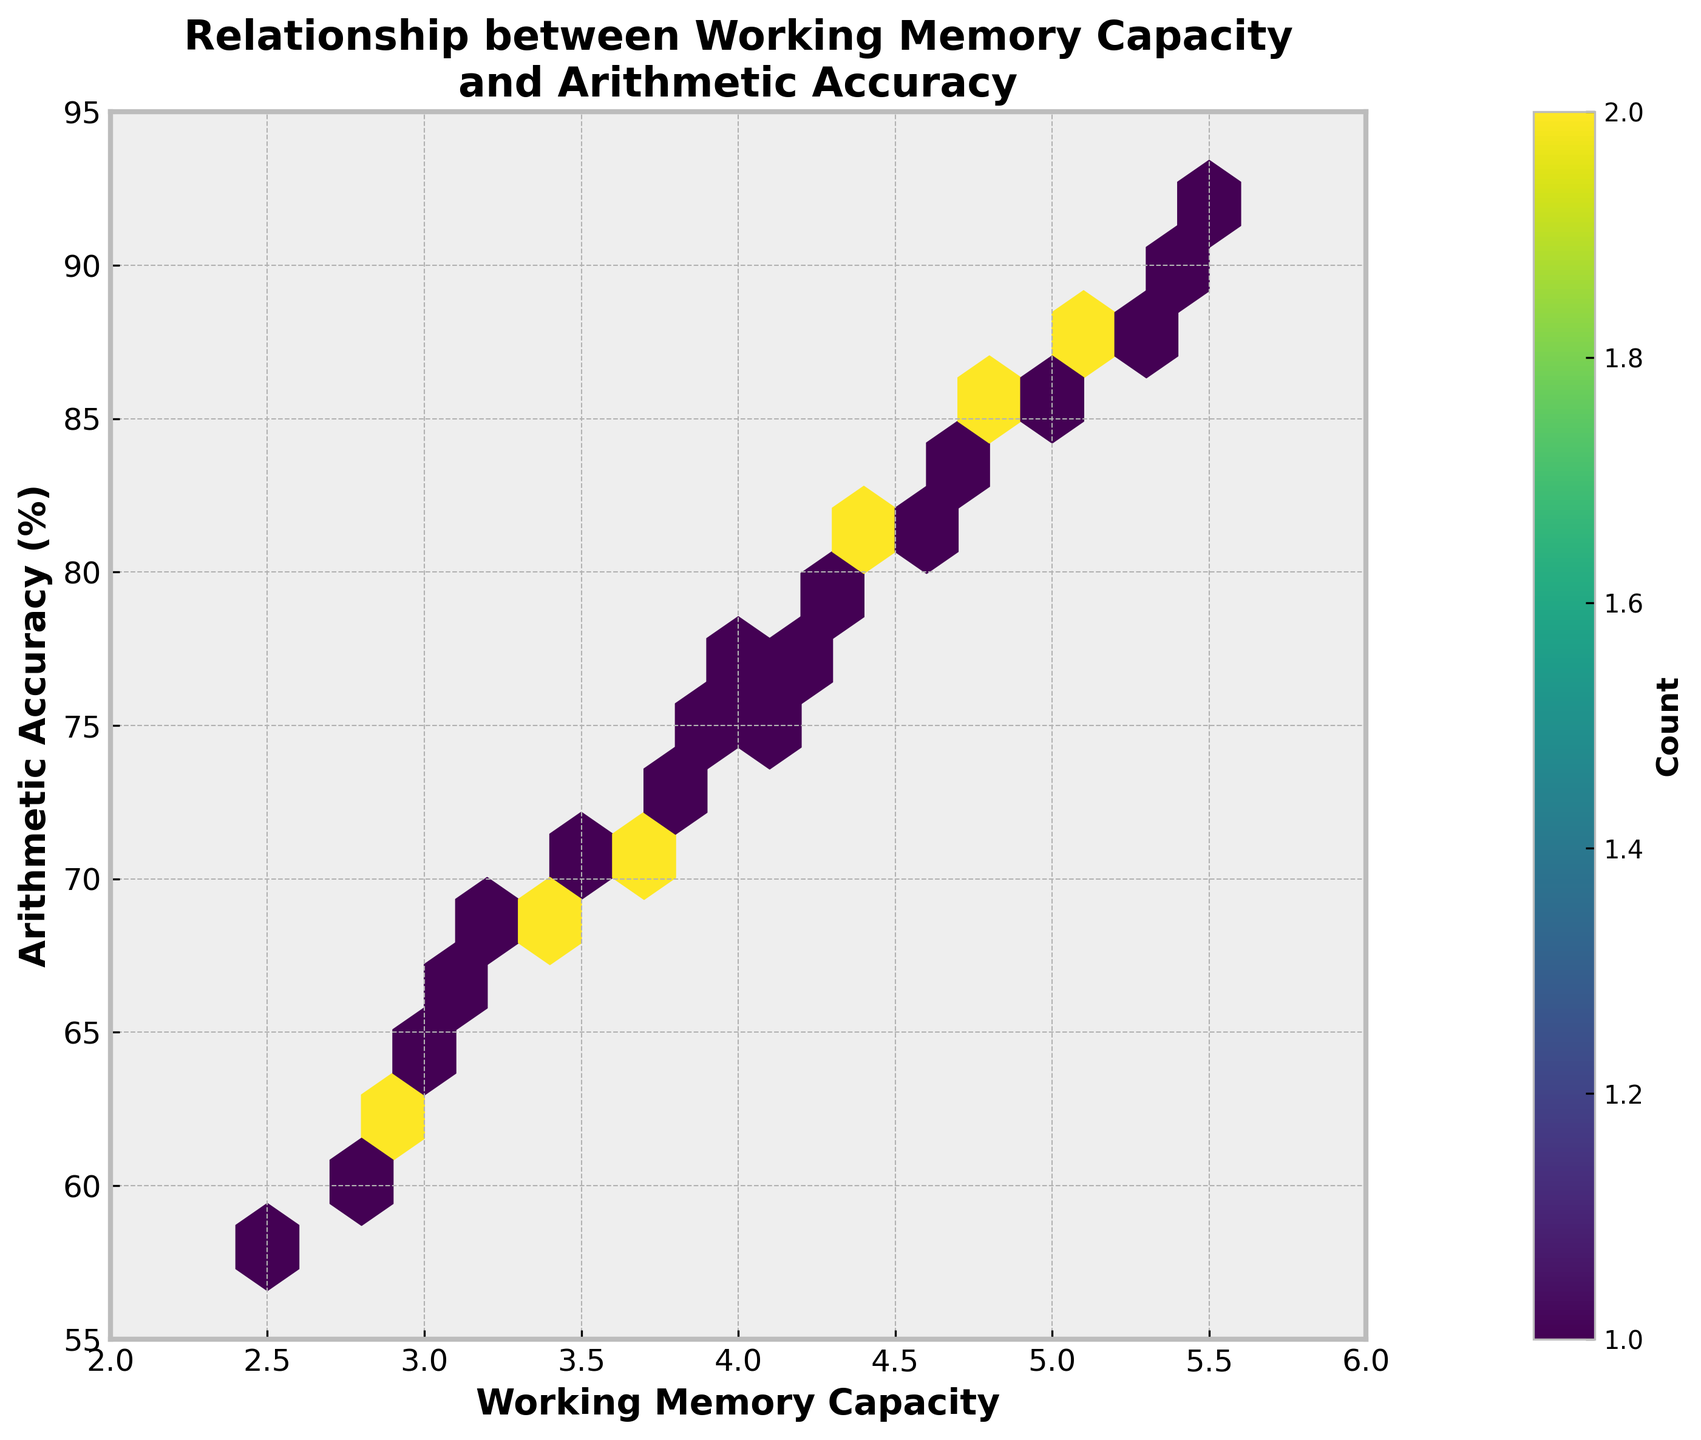What is the title of the plot? The title of the plot is displayed prominently at the top. It reads "Relationship between Working Memory Capacity and Arithmetic Accuracy." Therefore, one can infer this from visual inspection.
Answer: Relationship between Working Memory Capacity and Arithmetic Accuracy What are the labels of the axes? The x-axis label reads "Working Memory Capacity," and the y-axis label reads "Arithmetic Accuracy (%)." These are clearly marked to provide context for the data plotted.
Answer: Working Memory Capacity; Arithmetic Accuracy (%) What is the color of the densest hexbin region? The color of the densest hexbin regions is determined by the color map 'viridis,' which shifts from dark blue to bright yellow as density increases. The highest density regions are bright yellow.
Answer: Bright yellow How many hexagons are present in the plot? Counting each hexagon visually in the plot gridsized at 15, we see there are around 59 hexagons displayed. Each hexagon captures the density of data points in specific regions.
Answer: Approximately 59 What is the range of the x-axis? Looking at the x-axis from left to right, the range begins at 2 and ends at 6. These limits provide the spread of working memory capacity in the dataset.
Answer: 2 to 6 What is the range of the y-axis? Observing the y-axis, the range starts at 55 and extends to 95. This shows the spread of arithmetic accuracy percentages in the dataset.
Answer: 55 to 95 What working memory capacity corresponds to the highest arithmetic accuracy? From the plot, the highest arithmetic accuracy is around 92%, which corresponds to a working memory capacity of about 5.5. The data point lies near the upper boundary of the data range.
Answer: 5.5 What is the densest region of the plot? The densest region of the plot is where the yellow hexagons cluster, typically around a working memory capacity of 4.5-5.0 and an arithmetic accuracy of about 87-90%.
Answer: Around 4.5-5.0, 87-90% accuracy Is there a visible trend or relationship between working memory capacity and arithmetic accuracy? The hexbin plot shows a positive correlation trend, where an increase in working memory capacity generally corresponds to higher arithmetic accuracy. Most dense regions group at higher memory capacities and accuracies.
Answer: Yes, positive correlation How does the count distribution change as working memory capacity increases? As working memory capacity increases, the count distribution, indicated by the color transitioning from dark blue to bright yellow, shows more data points clustering at higher capacities, suggesting a denser and more significant number of individuals having higher accuracy at higher capacities.
Answer: Densities increase with capacity 